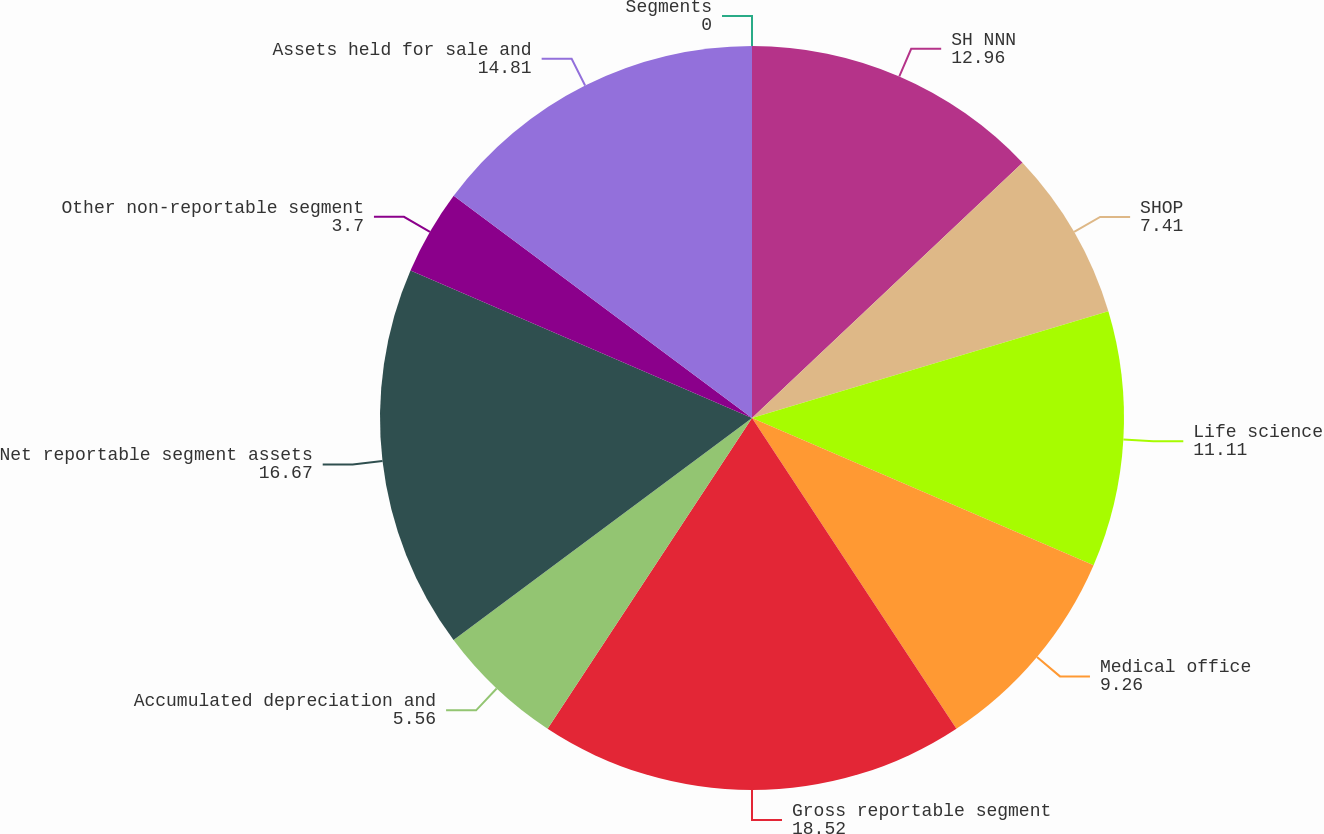Convert chart. <chart><loc_0><loc_0><loc_500><loc_500><pie_chart><fcel>Segments<fcel>SH NNN<fcel>SHOP<fcel>Life science<fcel>Medical office<fcel>Gross reportable segment<fcel>Accumulated depreciation and<fcel>Net reportable segment assets<fcel>Other non-reportable segment<fcel>Assets held for sale and<nl><fcel>0.0%<fcel>12.96%<fcel>7.41%<fcel>11.11%<fcel>9.26%<fcel>18.52%<fcel>5.56%<fcel>16.67%<fcel>3.7%<fcel>14.81%<nl></chart> 